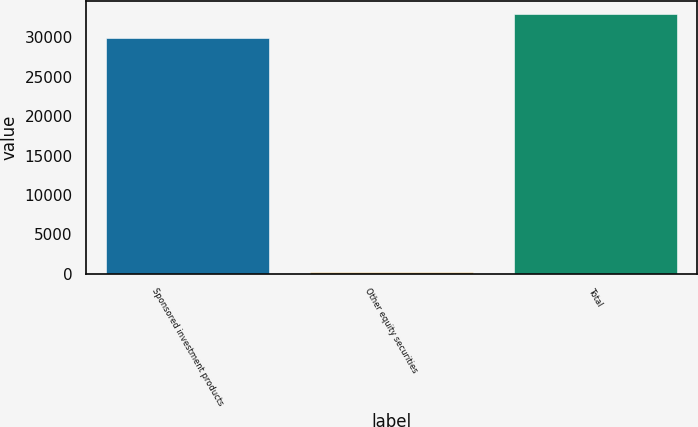Convert chart. <chart><loc_0><loc_0><loc_500><loc_500><bar_chart><fcel>Sponsored investment products<fcel>Other equity securities<fcel>Total<nl><fcel>29934<fcel>207<fcel>32930.4<nl></chart> 